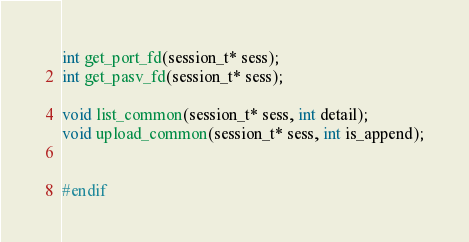Convert code to text. <code><loc_0><loc_0><loc_500><loc_500><_C_>int get_port_fd(session_t* sess);
int get_pasv_fd(session_t* sess);

void list_common(session_t* sess, int detail);
void upload_common(session_t* sess, int is_append);


#endif</code> 